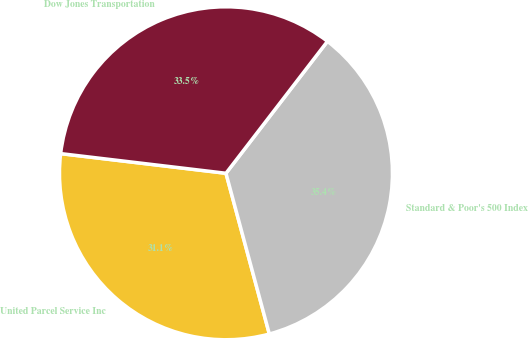Convert chart. <chart><loc_0><loc_0><loc_500><loc_500><pie_chart><fcel>United Parcel Service Inc<fcel>Standard & Poor's 500 Index<fcel>Dow Jones Transportation<nl><fcel>31.08%<fcel>35.37%<fcel>33.55%<nl></chart> 